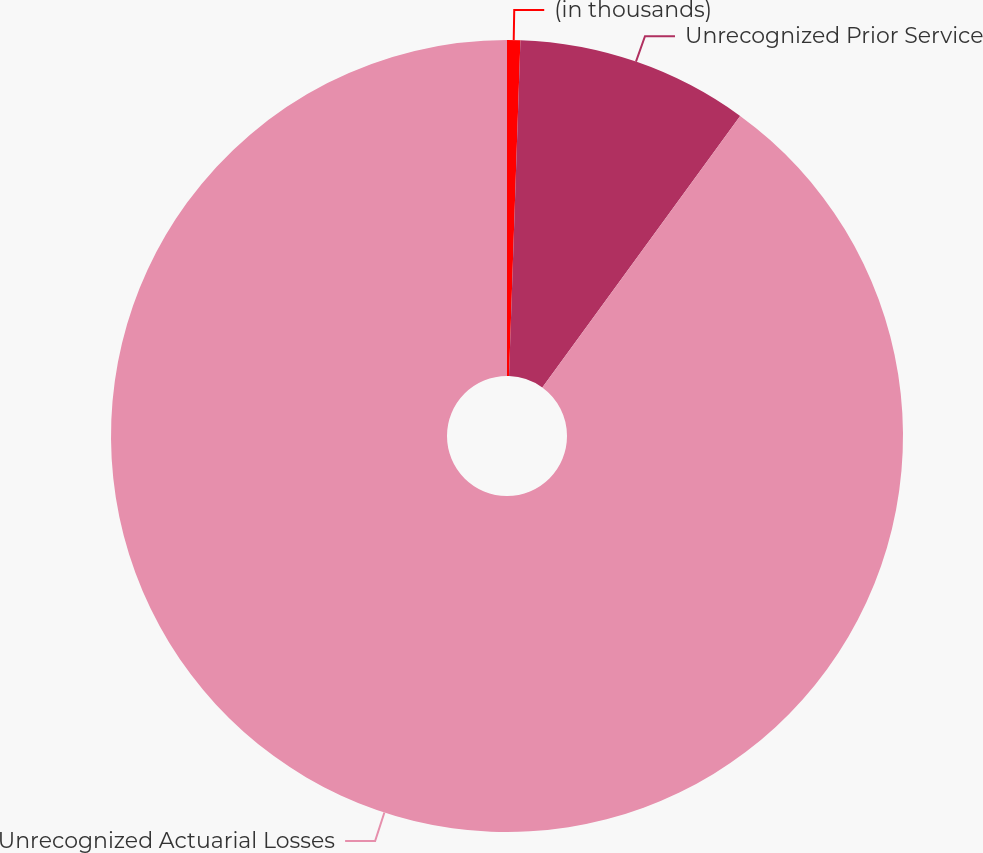Convert chart. <chart><loc_0><loc_0><loc_500><loc_500><pie_chart><fcel>(in thousands)<fcel>Unrecognized Prior Service<fcel>Unrecognized Actuarial Losses<nl><fcel>0.54%<fcel>9.48%<fcel>89.98%<nl></chart> 